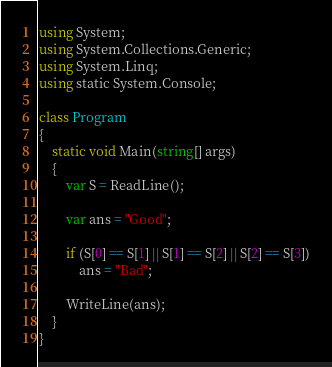Convert code to text. <code><loc_0><loc_0><loc_500><loc_500><_C#_>using System;
using System.Collections.Generic;
using System.Linq;
using static System.Console;

class Program
{
    static void Main(string[] args)
    {
        var S = ReadLine();

        var ans = "Good";

        if (S[0] == S[1] || S[1] == S[2] || S[2] == S[3])
            ans = "Bad";

        WriteLine(ans);
    }
}
</code> 